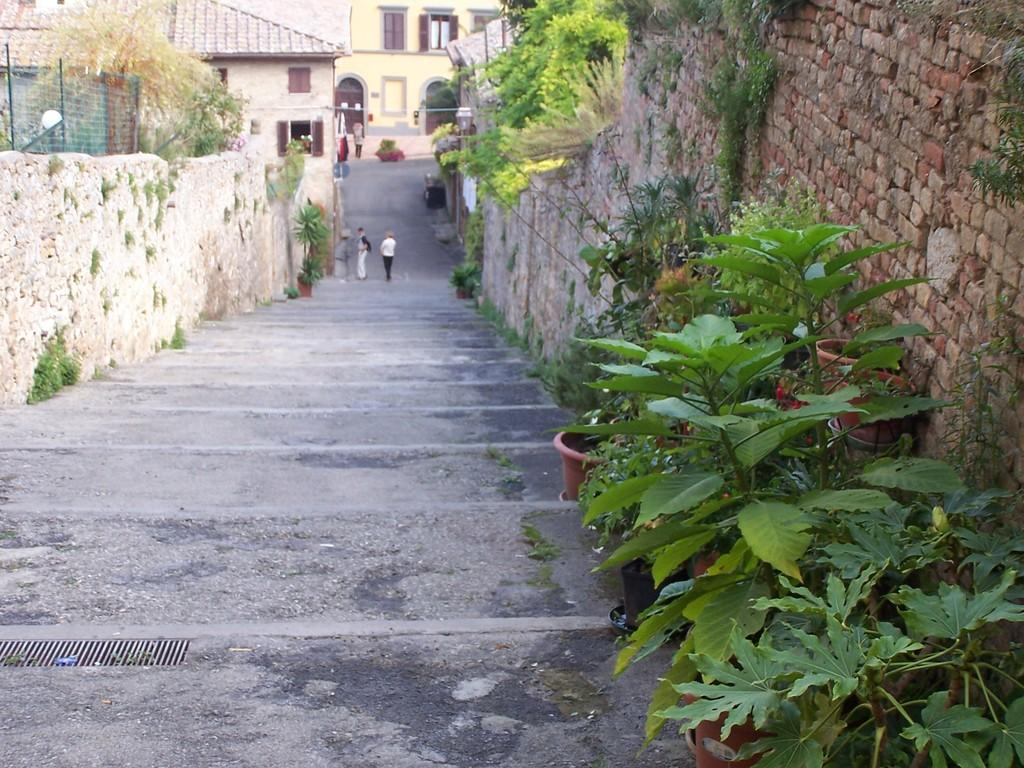What type of structures can be seen in the image? There are buildings in the image. What natural elements are present in the image? There are trees in the image. Are there any plants visible in the image? Yes, there are plants in pots in the image. Can you describe the people in the image? There are people standing in the image. What flavor of quicksand can be seen in the image? There is no quicksand present in the image, so it is not possible to determine its flavor. 